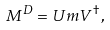<formula> <loc_0><loc_0><loc_500><loc_500>M ^ { D } = U m V ^ { \dag } ,</formula> 